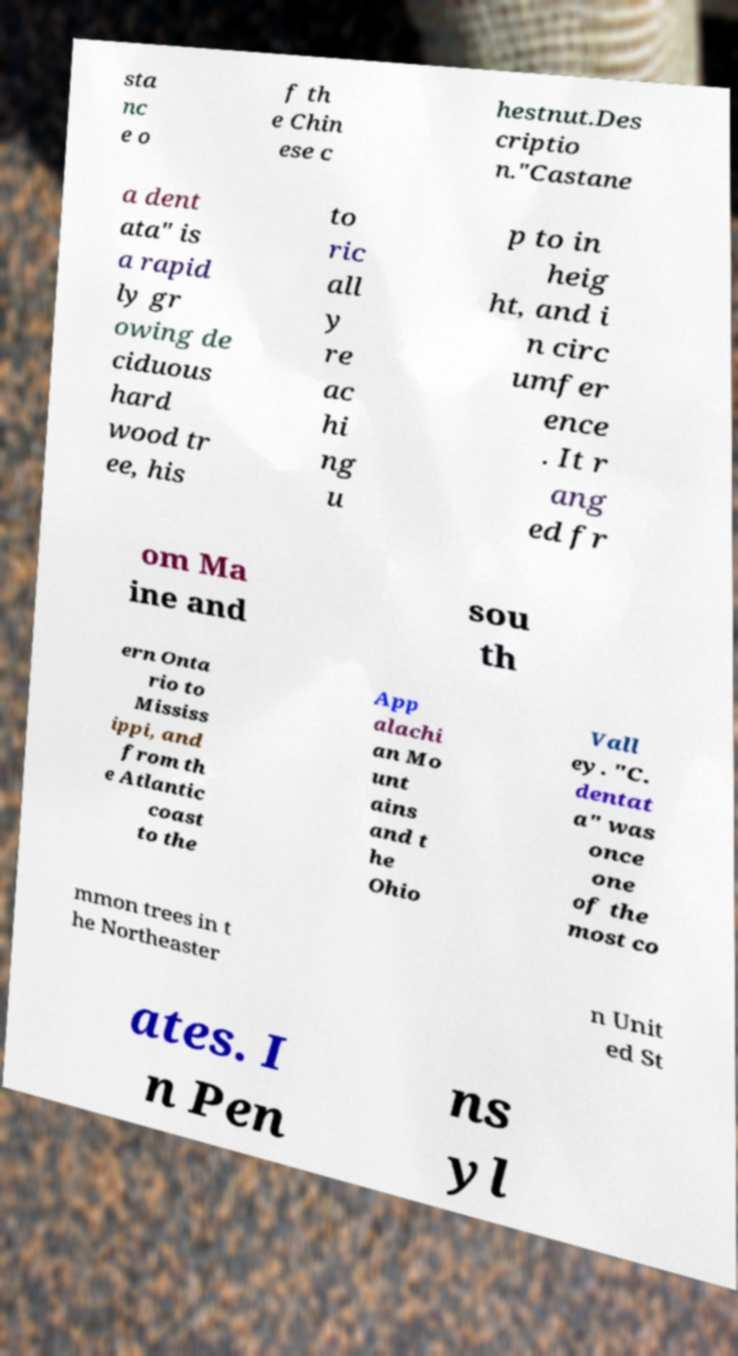What messages or text are displayed in this image? I need them in a readable, typed format. sta nc e o f th e Chin ese c hestnut.Des criptio n."Castane a dent ata" is a rapid ly gr owing de ciduous hard wood tr ee, his to ric all y re ac hi ng u p to in heig ht, and i n circ umfer ence . It r ang ed fr om Ma ine and sou th ern Onta rio to Mississ ippi, and from th e Atlantic coast to the App alachi an Mo unt ains and t he Ohio Vall ey. "C. dentat a" was once one of the most co mmon trees in t he Northeaster n Unit ed St ates. I n Pen ns yl 